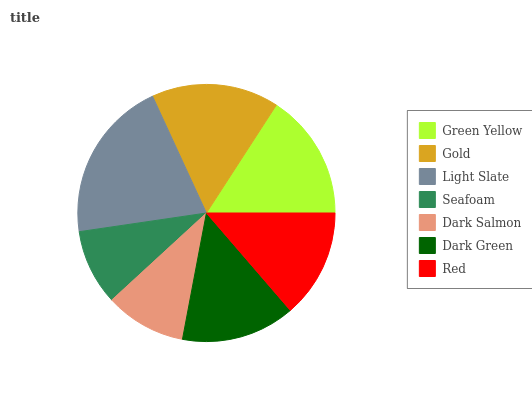Is Seafoam the minimum?
Answer yes or no. Yes. Is Light Slate the maximum?
Answer yes or no. Yes. Is Gold the minimum?
Answer yes or no. No. Is Gold the maximum?
Answer yes or no. No. Is Gold greater than Green Yellow?
Answer yes or no. Yes. Is Green Yellow less than Gold?
Answer yes or no. Yes. Is Green Yellow greater than Gold?
Answer yes or no. No. Is Gold less than Green Yellow?
Answer yes or no. No. Is Dark Green the high median?
Answer yes or no. Yes. Is Dark Green the low median?
Answer yes or no. Yes. Is Light Slate the high median?
Answer yes or no. No. Is Gold the low median?
Answer yes or no. No. 